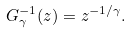<formula> <loc_0><loc_0><loc_500><loc_500>G _ { \gamma } ^ { - 1 } ( z ) = z ^ { - 1 / \gamma } .</formula> 